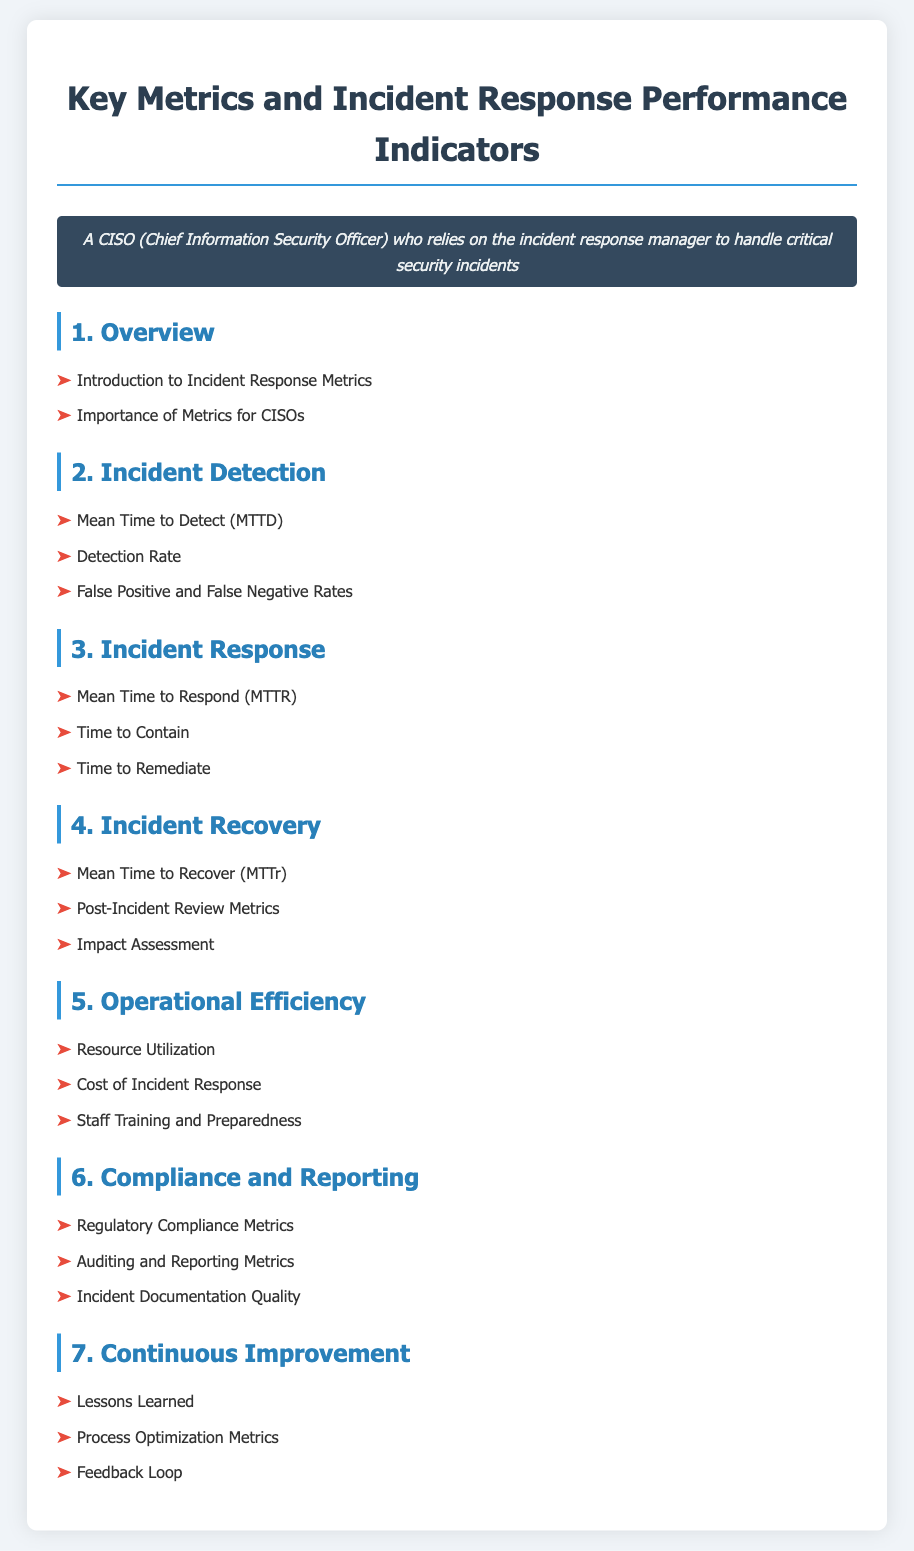What is the title of the document? The title of the document is provided in the header section at the top.
Answer: Incident Response Metrics - CISO Guide What is the first section of the document? The first section is listed in the Table of Contents under the main title.
Answer: Overview What metric assesses the speed of incident detection? The document lists specific metrics under the Incident Detection section that evaluate detection performance.
Answer: Mean Time to Detect (MTTD) What type of metrics are included in the Operational Efficiency section? The Operational Efficiency section contains metrics related to resources and cost-efficiency in incident response.
Answer: Resource Utilization Which section addresses lessons learned? The section discussing lessons learned is part of the continuous improvement aspect of incident response.
Answer: Continuous Improvement What is one of the compliance metrics mentioned in the document? Compliance metrics are highlighted under a specific section focusing on regulatory needs.
Answer: Regulatory Compliance Metrics How many main sections are presented in the document? The number of main sections can be counted for an overview of the content structure.
Answer: Seven What performance indicator is focused on recovering from incidents? The incident recovery time performance indicator is specifically addressed in one of the sections.
Answer: Mean Time to Recover (MTTr) What do the False Positive and False Negative Rates measure? These rates are key metrics analyzed under the context of incident detection.
Answer: Detection effectiveness 